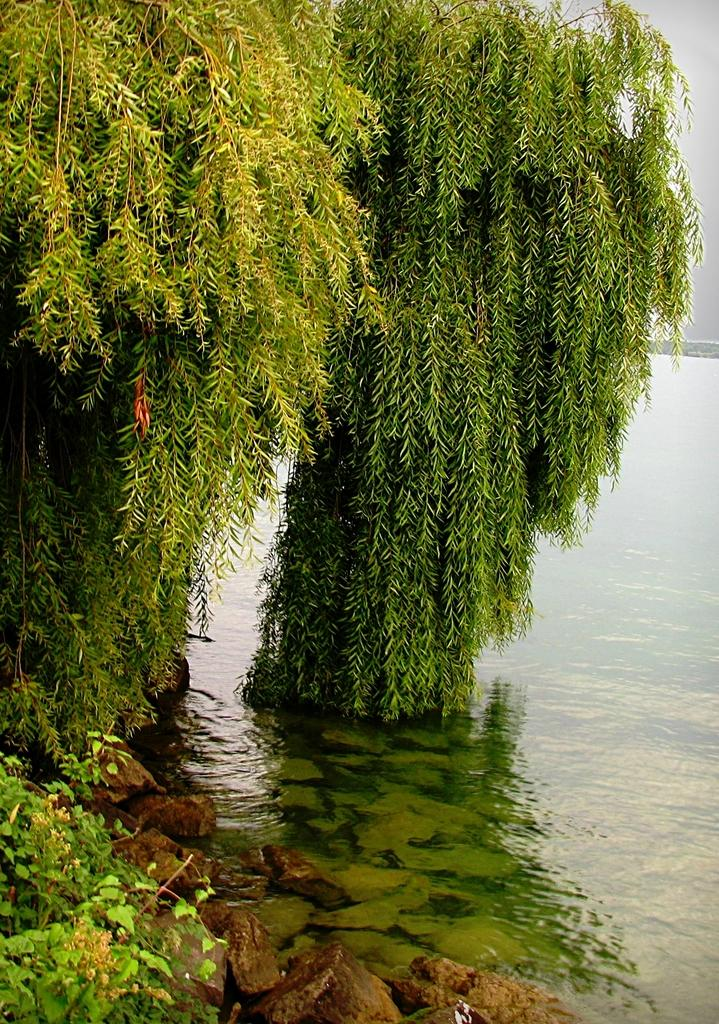What type of vegetation is on the left side of the image? There are trees on the left side of the image. What natural element is on the right side of the image? There is water on the right side of the image. What type of meal is being prepared in the image? There is no meal preparation visible in the image; it only features trees on the left side and water on the right side. What brass objects can be seen in the image? There are no brass objects present in the image. 